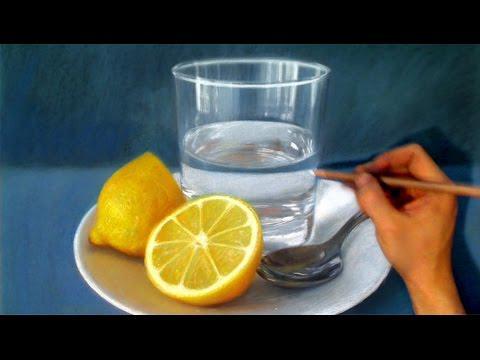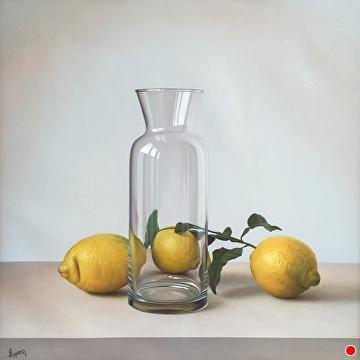The first image is the image on the left, the second image is the image on the right. Analyze the images presented: Is the assertion "The left image depicts a stemmed glass next to a whole lemon, and the right image includes a glass of clear liquid and a sliced fruit." valid? Answer yes or no. No. 